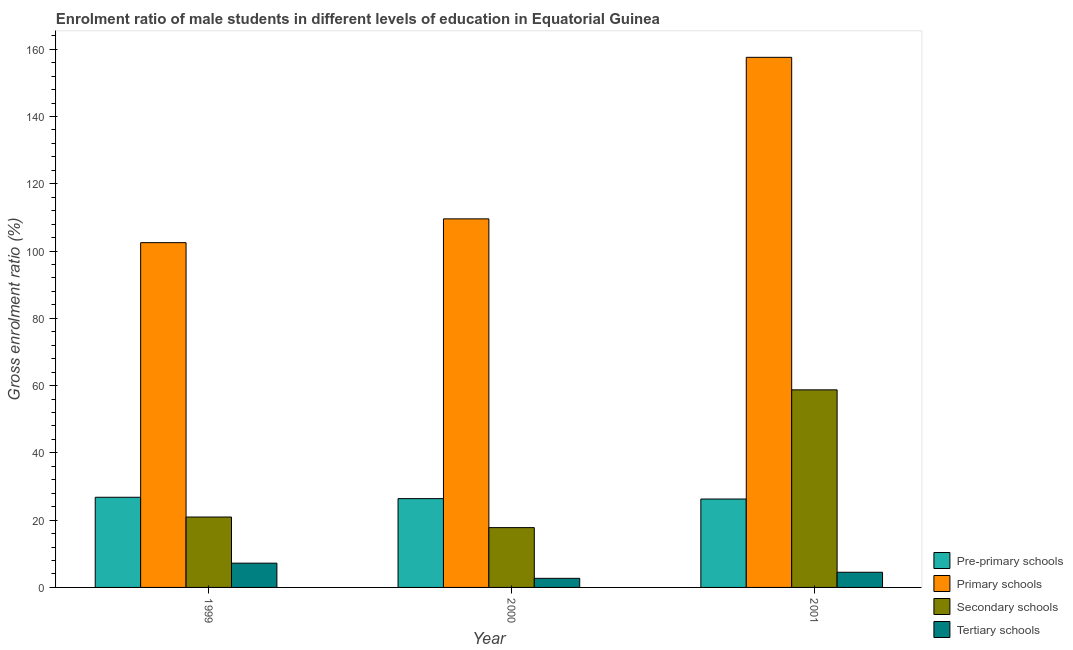Are the number of bars per tick equal to the number of legend labels?
Make the answer very short. Yes. How many bars are there on the 1st tick from the left?
Your answer should be very brief. 4. How many bars are there on the 3rd tick from the right?
Give a very brief answer. 4. What is the label of the 1st group of bars from the left?
Provide a succinct answer. 1999. In how many cases, is the number of bars for a given year not equal to the number of legend labels?
Your answer should be compact. 0. What is the gross enrolment ratio(female) in primary schools in 2001?
Ensure brevity in your answer.  157.61. Across all years, what is the maximum gross enrolment ratio(female) in pre-primary schools?
Your answer should be compact. 26.8. Across all years, what is the minimum gross enrolment ratio(female) in pre-primary schools?
Keep it short and to the point. 26.28. In which year was the gross enrolment ratio(female) in primary schools minimum?
Your response must be concise. 1999. What is the total gross enrolment ratio(female) in pre-primary schools in the graph?
Your answer should be compact. 79.49. What is the difference between the gross enrolment ratio(female) in secondary schools in 2000 and that in 2001?
Your answer should be compact. -40.96. What is the difference between the gross enrolment ratio(female) in tertiary schools in 1999 and the gross enrolment ratio(female) in primary schools in 2000?
Your response must be concise. 4.51. What is the average gross enrolment ratio(female) in primary schools per year?
Provide a succinct answer. 123.23. In the year 1999, what is the difference between the gross enrolment ratio(female) in pre-primary schools and gross enrolment ratio(female) in secondary schools?
Offer a terse response. 0. In how many years, is the gross enrolment ratio(female) in primary schools greater than 44 %?
Provide a succinct answer. 3. What is the ratio of the gross enrolment ratio(female) in pre-primary schools in 2000 to that in 2001?
Ensure brevity in your answer.  1. Is the difference between the gross enrolment ratio(female) in secondary schools in 1999 and 2000 greater than the difference between the gross enrolment ratio(female) in tertiary schools in 1999 and 2000?
Give a very brief answer. No. What is the difference between the highest and the second highest gross enrolment ratio(female) in pre-primary schools?
Make the answer very short. 0.4. What is the difference between the highest and the lowest gross enrolment ratio(female) in primary schools?
Offer a terse response. 55.1. In how many years, is the gross enrolment ratio(female) in primary schools greater than the average gross enrolment ratio(female) in primary schools taken over all years?
Keep it short and to the point. 1. Is it the case that in every year, the sum of the gross enrolment ratio(female) in tertiary schools and gross enrolment ratio(female) in pre-primary schools is greater than the sum of gross enrolment ratio(female) in primary schools and gross enrolment ratio(female) in secondary schools?
Your response must be concise. No. What does the 4th bar from the left in 1999 represents?
Ensure brevity in your answer.  Tertiary schools. What does the 2nd bar from the right in 1999 represents?
Keep it short and to the point. Secondary schools. Is it the case that in every year, the sum of the gross enrolment ratio(female) in pre-primary schools and gross enrolment ratio(female) in primary schools is greater than the gross enrolment ratio(female) in secondary schools?
Make the answer very short. Yes. Are all the bars in the graph horizontal?
Offer a terse response. No. How many years are there in the graph?
Keep it short and to the point. 3. What is the difference between two consecutive major ticks on the Y-axis?
Keep it short and to the point. 20. Are the values on the major ticks of Y-axis written in scientific E-notation?
Provide a succinct answer. No. Does the graph contain any zero values?
Keep it short and to the point. No. Does the graph contain grids?
Make the answer very short. No. How many legend labels are there?
Your response must be concise. 4. How are the legend labels stacked?
Your answer should be very brief. Vertical. What is the title of the graph?
Give a very brief answer. Enrolment ratio of male students in different levels of education in Equatorial Guinea. Does "Social equity" appear as one of the legend labels in the graph?
Ensure brevity in your answer.  No. What is the Gross enrolment ratio (%) in Pre-primary schools in 1999?
Your answer should be very brief. 26.8. What is the Gross enrolment ratio (%) in Primary schools in 1999?
Your answer should be very brief. 102.51. What is the Gross enrolment ratio (%) in Secondary schools in 1999?
Your response must be concise. 20.93. What is the Gross enrolment ratio (%) of Tertiary schools in 1999?
Your response must be concise. 7.21. What is the Gross enrolment ratio (%) of Pre-primary schools in 2000?
Your answer should be very brief. 26.4. What is the Gross enrolment ratio (%) of Primary schools in 2000?
Your response must be concise. 109.58. What is the Gross enrolment ratio (%) of Secondary schools in 2000?
Ensure brevity in your answer.  17.78. What is the Gross enrolment ratio (%) in Tertiary schools in 2000?
Give a very brief answer. 2.7. What is the Gross enrolment ratio (%) in Pre-primary schools in 2001?
Ensure brevity in your answer.  26.28. What is the Gross enrolment ratio (%) in Primary schools in 2001?
Make the answer very short. 157.61. What is the Gross enrolment ratio (%) in Secondary schools in 2001?
Offer a very short reply. 58.74. What is the Gross enrolment ratio (%) of Tertiary schools in 2001?
Keep it short and to the point. 4.51. Across all years, what is the maximum Gross enrolment ratio (%) of Pre-primary schools?
Your answer should be compact. 26.8. Across all years, what is the maximum Gross enrolment ratio (%) of Primary schools?
Ensure brevity in your answer.  157.61. Across all years, what is the maximum Gross enrolment ratio (%) of Secondary schools?
Ensure brevity in your answer.  58.74. Across all years, what is the maximum Gross enrolment ratio (%) in Tertiary schools?
Provide a short and direct response. 7.21. Across all years, what is the minimum Gross enrolment ratio (%) in Pre-primary schools?
Provide a short and direct response. 26.28. Across all years, what is the minimum Gross enrolment ratio (%) in Primary schools?
Ensure brevity in your answer.  102.51. Across all years, what is the minimum Gross enrolment ratio (%) in Secondary schools?
Your response must be concise. 17.78. Across all years, what is the minimum Gross enrolment ratio (%) of Tertiary schools?
Make the answer very short. 2.7. What is the total Gross enrolment ratio (%) in Pre-primary schools in the graph?
Offer a terse response. 79.49. What is the total Gross enrolment ratio (%) of Primary schools in the graph?
Give a very brief answer. 369.69. What is the total Gross enrolment ratio (%) in Secondary schools in the graph?
Offer a very short reply. 97.46. What is the total Gross enrolment ratio (%) in Tertiary schools in the graph?
Your answer should be very brief. 14.43. What is the difference between the Gross enrolment ratio (%) in Pre-primary schools in 1999 and that in 2000?
Offer a terse response. 0.4. What is the difference between the Gross enrolment ratio (%) in Primary schools in 1999 and that in 2000?
Your answer should be compact. -7.07. What is the difference between the Gross enrolment ratio (%) of Secondary schools in 1999 and that in 2000?
Your answer should be very brief. 3.15. What is the difference between the Gross enrolment ratio (%) in Tertiary schools in 1999 and that in 2000?
Your answer should be very brief. 4.51. What is the difference between the Gross enrolment ratio (%) in Pre-primary schools in 1999 and that in 2001?
Give a very brief answer. 0.52. What is the difference between the Gross enrolment ratio (%) of Primary schools in 1999 and that in 2001?
Offer a terse response. -55.1. What is the difference between the Gross enrolment ratio (%) of Secondary schools in 1999 and that in 2001?
Your answer should be very brief. -37.81. What is the difference between the Gross enrolment ratio (%) in Tertiary schools in 1999 and that in 2001?
Ensure brevity in your answer.  2.7. What is the difference between the Gross enrolment ratio (%) of Pre-primary schools in 2000 and that in 2001?
Make the answer very short. 0.12. What is the difference between the Gross enrolment ratio (%) in Primary schools in 2000 and that in 2001?
Make the answer very short. -48.03. What is the difference between the Gross enrolment ratio (%) of Secondary schools in 2000 and that in 2001?
Give a very brief answer. -40.96. What is the difference between the Gross enrolment ratio (%) of Tertiary schools in 2000 and that in 2001?
Your response must be concise. -1.81. What is the difference between the Gross enrolment ratio (%) of Pre-primary schools in 1999 and the Gross enrolment ratio (%) of Primary schools in 2000?
Ensure brevity in your answer.  -82.77. What is the difference between the Gross enrolment ratio (%) of Pre-primary schools in 1999 and the Gross enrolment ratio (%) of Secondary schools in 2000?
Offer a terse response. 9.02. What is the difference between the Gross enrolment ratio (%) in Pre-primary schools in 1999 and the Gross enrolment ratio (%) in Tertiary schools in 2000?
Keep it short and to the point. 24.1. What is the difference between the Gross enrolment ratio (%) in Primary schools in 1999 and the Gross enrolment ratio (%) in Secondary schools in 2000?
Ensure brevity in your answer.  84.72. What is the difference between the Gross enrolment ratio (%) in Primary schools in 1999 and the Gross enrolment ratio (%) in Tertiary schools in 2000?
Your answer should be compact. 99.8. What is the difference between the Gross enrolment ratio (%) in Secondary schools in 1999 and the Gross enrolment ratio (%) in Tertiary schools in 2000?
Keep it short and to the point. 18.23. What is the difference between the Gross enrolment ratio (%) in Pre-primary schools in 1999 and the Gross enrolment ratio (%) in Primary schools in 2001?
Give a very brief answer. -130.8. What is the difference between the Gross enrolment ratio (%) of Pre-primary schools in 1999 and the Gross enrolment ratio (%) of Secondary schools in 2001?
Make the answer very short. -31.94. What is the difference between the Gross enrolment ratio (%) of Pre-primary schools in 1999 and the Gross enrolment ratio (%) of Tertiary schools in 2001?
Offer a very short reply. 22.29. What is the difference between the Gross enrolment ratio (%) of Primary schools in 1999 and the Gross enrolment ratio (%) of Secondary schools in 2001?
Keep it short and to the point. 43.76. What is the difference between the Gross enrolment ratio (%) of Primary schools in 1999 and the Gross enrolment ratio (%) of Tertiary schools in 2001?
Offer a very short reply. 98. What is the difference between the Gross enrolment ratio (%) of Secondary schools in 1999 and the Gross enrolment ratio (%) of Tertiary schools in 2001?
Provide a short and direct response. 16.42. What is the difference between the Gross enrolment ratio (%) in Pre-primary schools in 2000 and the Gross enrolment ratio (%) in Primary schools in 2001?
Your response must be concise. -131.2. What is the difference between the Gross enrolment ratio (%) in Pre-primary schools in 2000 and the Gross enrolment ratio (%) in Secondary schools in 2001?
Your response must be concise. -32.34. What is the difference between the Gross enrolment ratio (%) of Pre-primary schools in 2000 and the Gross enrolment ratio (%) of Tertiary schools in 2001?
Offer a very short reply. 21.89. What is the difference between the Gross enrolment ratio (%) of Primary schools in 2000 and the Gross enrolment ratio (%) of Secondary schools in 2001?
Your response must be concise. 50.83. What is the difference between the Gross enrolment ratio (%) in Primary schools in 2000 and the Gross enrolment ratio (%) in Tertiary schools in 2001?
Offer a very short reply. 105.07. What is the difference between the Gross enrolment ratio (%) of Secondary schools in 2000 and the Gross enrolment ratio (%) of Tertiary schools in 2001?
Ensure brevity in your answer.  13.27. What is the average Gross enrolment ratio (%) in Pre-primary schools per year?
Offer a very short reply. 26.5. What is the average Gross enrolment ratio (%) in Primary schools per year?
Ensure brevity in your answer.  123.23. What is the average Gross enrolment ratio (%) in Secondary schools per year?
Ensure brevity in your answer.  32.49. What is the average Gross enrolment ratio (%) in Tertiary schools per year?
Offer a very short reply. 4.81. In the year 1999, what is the difference between the Gross enrolment ratio (%) in Pre-primary schools and Gross enrolment ratio (%) in Primary schools?
Ensure brevity in your answer.  -75.7. In the year 1999, what is the difference between the Gross enrolment ratio (%) of Pre-primary schools and Gross enrolment ratio (%) of Secondary schools?
Your response must be concise. 5.87. In the year 1999, what is the difference between the Gross enrolment ratio (%) in Pre-primary schools and Gross enrolment ratio (%) in Tertiary schools?
Your answer should be very brief. 19.59. In the year 1999, what is the difference between the Gross enrolment ratio (%) of Primary schools and Gross enrolment ratio (%) of Secondary schools?
Your answer should be very brief. 81.58. In the year 1999, what is the difference between the Gross enrolment ratio (%) of Primary schools and Gross enrolment ratio (%) of Tertiary schools?
Offer a terse response. 95.29. In the year 1999, what is the difference between the Gross enrolment ratio (%) in Secondary schools and Gross enrolment ratio (%) in Tertiary schools?
Provide a succinct answer. 13.72. In the year 2000, what is the difference between the Gross enrolment ratio (%) of Pre-primary schools and Gross enrolment ratio (%) of Primary schools?
Make the answer very short. -83.17. In the year 2000, what is the difference between the Gross enrolment ratio (%) of Pre-primary schools and Gross enrolment ratio (%) of Secondary schools?
Make the answer very short. 8.62. In the year 2000, what is the difference between the Gross enrolment ratio (%) of Pre-primary schools and Gross enrolment ratio (%) of Tertiary schools?
Give a very brief answer. 23.7. In the year 2000, what is the difference between the Gross enrolment ratio (%) of Primary schools and Gross enrolment ratio (%) of Secondary schools?
Your answer should be very brief. 91.79. In the year 2000, what is the difference between the Gross enrolment ratio (%) of Primary schools and Gross enrolment ratio (%) of Tertiary schools?
Provide a succinct answer. 106.87. In the year 2000, what is the difference between the Gross enrolment ratio (%) in Secondary schools and Gross enrolment ratio (%) in Tertiary schools?
Your answer should be compact. 15.08. In the year 2001, what is the difference between the Gross enrolment ratio (%) of Pre-primary schools and Gross enrolment ratio (%) of Primary schools?
Provide a short and direct response. -131.32. In the year 2001, what is the difference between the Gross enrolment ratio (%) of Pre-primary schools and Gross enrolment ratio (%) of Secondary schools?
Offer a very short reply. -32.46. In the year 2001, what is the difference between the Gross enrolment ratio (%) in Pre-primary schools and Gross enrolment ratio (%) in Tertiary schools?
Offer a terse response. 21.77. In the year 2001, what is the difference between the Gross enrolment ratio (%) in Primary schools and Gross enrolment ratio (%) in Secondary schools?
Provide a short and direct response. 98.86. In the year 2001, what is the difference between the Gross enrolment ratio (%) of Primary schools and Gross enrolment ratio (%) of Tertiary schools?
Your response must be concise. 153.09. In the year 2001, what is the difference between the Gross enrolment ratio (%) of Secondary schools and Gross enrolment ratio (%) of Tertiary schools?
Make the answer very short. 54.23. What is the ratio of the Gross enrolment ratio (%) of Pre-primary schools in 1999 to that in 2000?
Your answer should be compact. 1.02. What is the ratio of the Gross enrolment ratio (%) of Primary schools in 1999 to that in 2000?
Keep it short and to the point. 0.94. What is the ratio of the Gross enrolment ratio (%) in Secondary schools in 1999 to that in 2000?
Keep it short and to the point. 1.18. What is the ratio of the Gross enrolment ratio (%) of Tertiary schools in 1999 to that in 2000?
Provide a succinct answer. 2.67. What is the ratio of the Gross enrolment ratio (%) of Pre-primary schools in 1999 to that in 2001?
Ensure brevity in your answer.  1.02. What is the ratio of the Gross enrolment ratio (%) in Primary schools in 1999 to that in 2001?
Offer a terse response. 0.65. What is the ratio of the Gross enrolment ratio (%) in Secondary schools in 1999 to that in 2001?
Ensure brevity in your answer.  0.36. What is the ratio of the Gross enrolment ratio (%) of Tertiary schools in 1999 to that in 2001?
Ensure brevity in your answer.  1.6. What is the ratio of the Gross enrolment ratio (%) in Primary schools in 2000 to that in 2001?
Offer a very short reply. 0.7. What is the ratio of the Gross enrolment ratio (%) in Secondary schools in 2000 to that in 2001?
Provide a succinct answer. 0.3. What is the ratio of the Gross enrolment ratio (%) of Tertiary schools in 2000 to that in 2001?
Your answer should be very brief. 0.6. What is the difference between the highest and the second highest Gross enrolment ratio (%) of Pre-primary schools?
Ensure brevity in your answer.  0.4. What is the difference between the highest and the second highest Gross enrolment ratio (%) in Primary schools?
Your answer should be very brief. 48.03. What is the difference between the highest and the second highest Gross enrolment ratio (%) of Secondary schools?
Provide a short and direct response. 37.81. What is the difference between the highest and the second highest Gross enrolment ratio (%) of Tertiary schools?
Keep it short and to the point. 2.7. What is the difference between the highest and the lowest Gross enrolment ratio (%) in Pre-primary schools?
Offer a very short reply. 0.52. What is the difference between the highest and the lowest Gross enrolment ratio (%) in Primary schools?
Your response must be concise. 55.1. What is the difference between the highest and the lowest Gross enrolment ratio (%) of Secondary schools?
Provide a short and direct response. 40.96. What is the difference between the highest and the lowest Gross enrolment ratio (%) in Tertiary schools?
Keep it short and to the point. 4.51. 